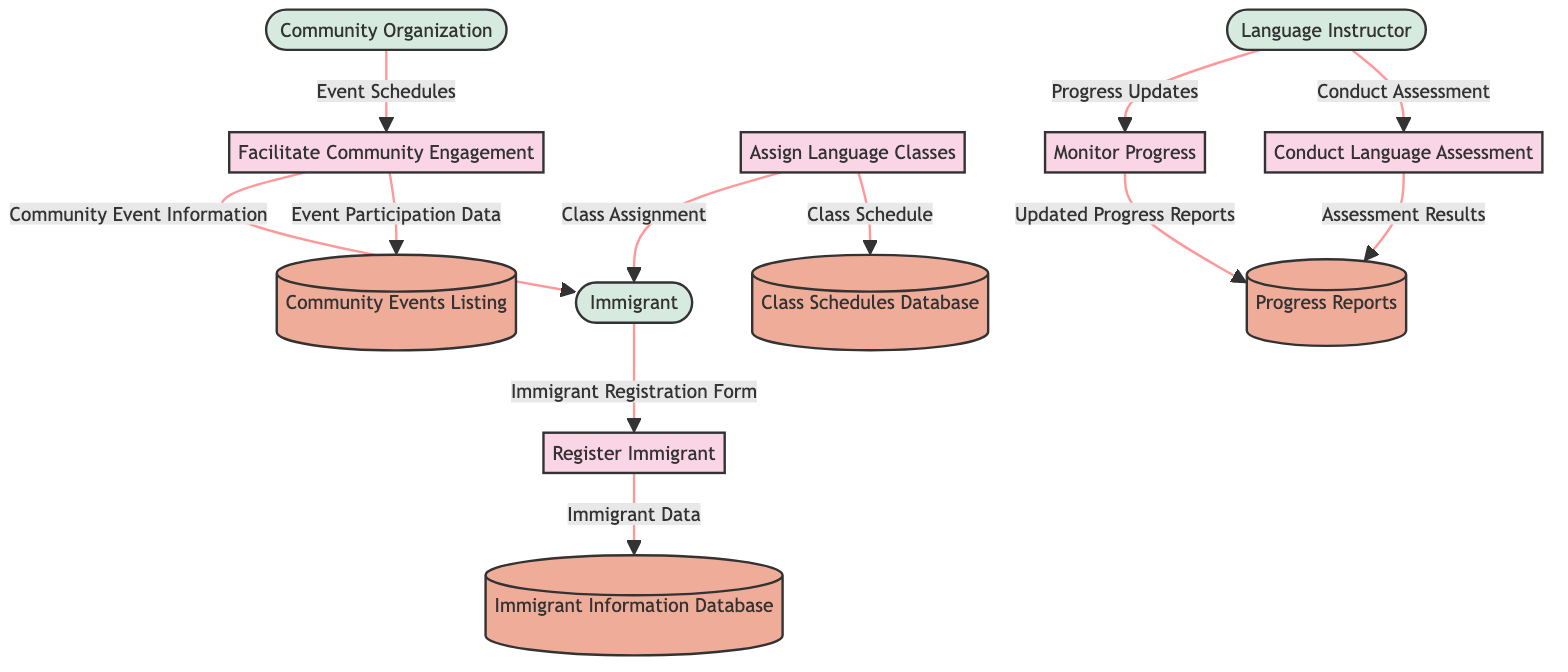What is the first process in the diagram? The first process is identified as "Register Immigrant," which is labeled as P1 in the diagram. It is the starting point for the data flow related to immigrant registration.
Answer: Register Immigrant How many data stores are presented in the diagram? The diagram contains four data stores labeled as D1, D2, D3, and D4, which are shown as databases within the system.
Answer: Four What relationship exists between the "Language Instructor" and the "Conduct Language Assessment" process? The "Language Instructor" (E2) conducts the assessment, which flows into the "Conduct Language Assessment" process (P2) as indicated by the labeled arrow connecting them in the diagram.
Answer: Conduct Assessment Which entity receives the "Class Assignment"? The "Immigrant" (E1) is the entity receiving the "Class Assignment," which is clearly shown to flow from the "Assign Language Classes" process (P3) to E1.
Answer: Immigrant What data is stored in the "Progress Reports" data store? The "Progress Reports" (D3) data store contains the "Assessment Results" and "Updated Progress Reports," as indicated by the flows from the processes to D3.
Answer: Assessment Results and Updated Progress Reports How does the "Facilitate Community Engagement" process interact with the "Community Organization"? The "Facilitate Community Engagement" process (P5) receives "Event Schedules" from the "Community Organization" (E3) and also sends "Community Event Information" to the "Immigrant" (E1). This interaction shows that P5 relies on E3 for scheduling events.
Answer: Event Schedules Which data store holds the "Event Participation Data"? The data store identified as "Community Events Listing" (D4) holds the "Event Participation Data," which is generated from the "Facilitate Community Engagement" process (P5).
Answer: Community Events Listing Which process is responsible for the "Updated Progress Reports"? The "Monitor Progress" process (P4) is responsible for generating the "Updated Progress Reports," which is reflected in the flow to the D3 data store.
Answer: Monitor Progress What type of information does the "Immigrant Registration Form" provide? The "Immigrant Registration Form" provides "Immigrant Data" to the "Register Immigrant" process (P1), which is essential for the initial data entry related to immigrant information.
Answer: Immigrant Data 